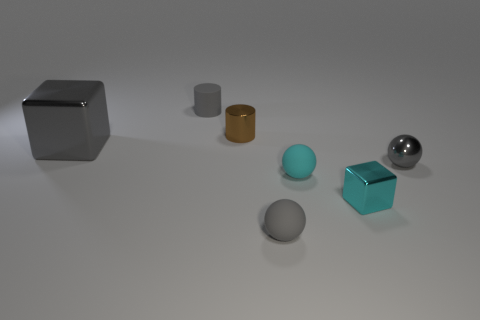There is a cyan sphere; is its size the same as the gray metallic object behind the small shiny sphere?
Your answer should be compact. No. Is the number of small things that are on the right side of the brown cylinder less than the number of cyan shiny objects that are behind the cyan metallic block?
Provide a succinct answer. No. How big is the gray metallic thing that is right of the gray cylinder?
Keep it short and to the point. Small. Is the gray cube the same size as the metal sphere?
Give a very brief answer. No. What number of small objects are left of the small cyan metallic cube and right of the small brown metallic cylinder?
Your answer should be very brief. 2. How many green things are either large metal cubes or small spheres?
Your answer should be very brief. 0. How many shiny objects are either cyan objects or blocks?
Offer a very short reply. 2. Is there a large yellow rubber cube?
Offer a very short reply. No. Do the large gray object and the tiny cyan metal thing have the same shape?
Provide a short and direct response. Yes. What number of cyan rubber balls are in front of the cyan metal thing that is in front of the small cylinder behind the small brown cylinder?
Your answer should be compact. 0. 